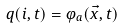<formula> <loc_0><loc_0><loc_500><loc_500>q ( i , t ) = \varphi _ { a } ( \vec { x } , t )</formula> 